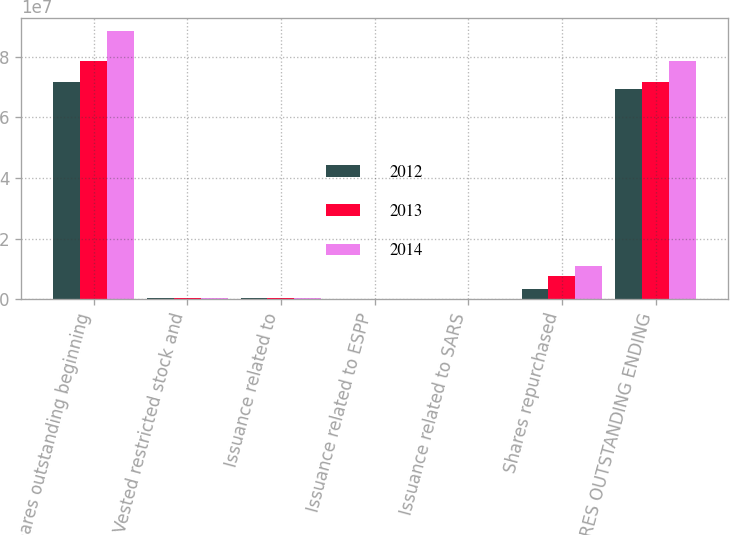<chart> <loc_0><loc_0><loc_500><loc_500><stacked_bar_chart><ecel><fcel>Shares outstanding beginning<fcel>Vested restricted stock and<fcel>Issuance related to<fcel>Issuance related to ESPP<fcel>Issuance related to SARS<fcel>Shares repurchased<fcel>SHARES OUTSTANDING ENDING<nl><fcel>2012<fcel>7.18282e+07<fcel>321841<fcel>277164<fcel>141576<fcel>29260<fcel>3.29849e+06<fcel>6.92996e+07<nl><fcel>2013<fcel>7.8664e+07<fcel>340525<fcel>252025<fcel>217573<fcel>61070<fcel>7.70701e+06<fcel>7.18282e+07<nl><fcel>2014<fcel>8.85244e+07<fcel>370244<fcel>403519<fcel>213942<fcel>51410<fcel>1.08995e+07<fcel>7.8664e+07<nl></chart> 